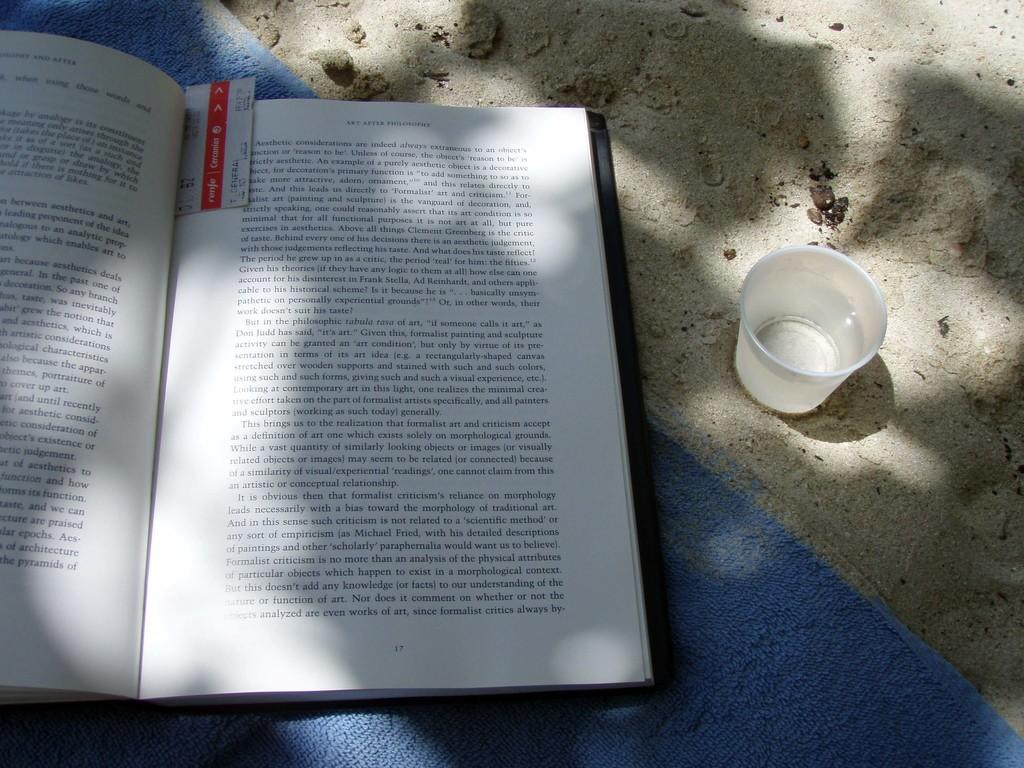<image>
Write a terse but informative summary of the picture. An open book sitting in the sand, something about a critic named Clement Greenberg is written on the page. 